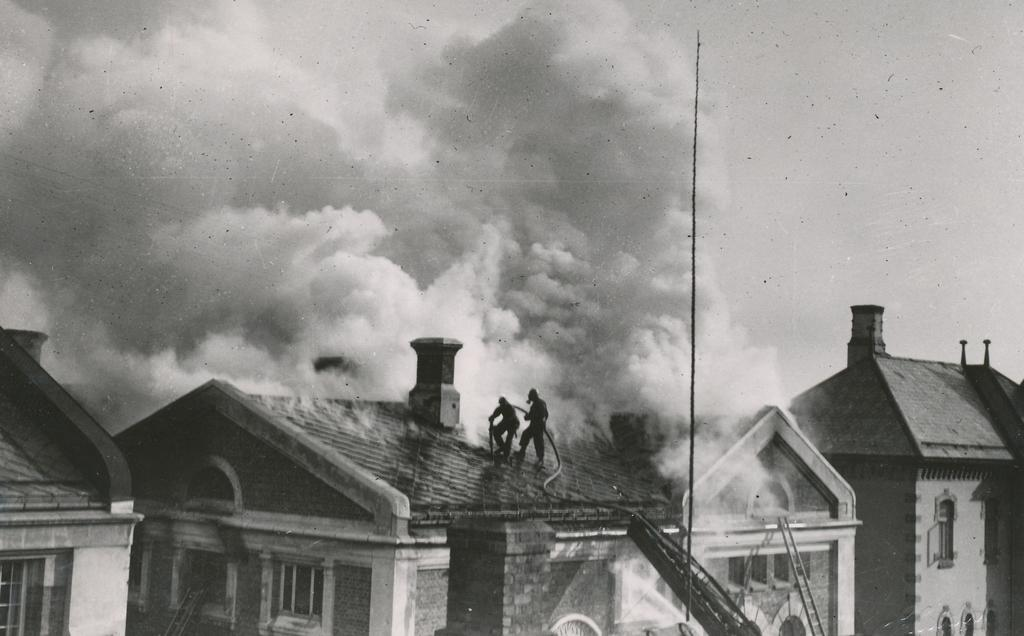What type of structures can be seen in the image? There are houses in the image. What object is present that can be used for climbing or reaching higher places? There is a ladder in the image. What are the two persons doing in the image? They are holding a pipe and standing on the roof of a house. What can be seen in the air in the image? There is smoke in the image. What is visible in the background of the image? The sky is visible in the background of the image. Where is the jail located in the image? There is no jail present in the image. What type of gardening tool is being used by the persons in the image? The persons in the image are not using any gardening tools; they are holding a pipe. 